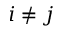<formula> <loc_0><loc_0><loc_500><loc_500>i \neq j</formula> 